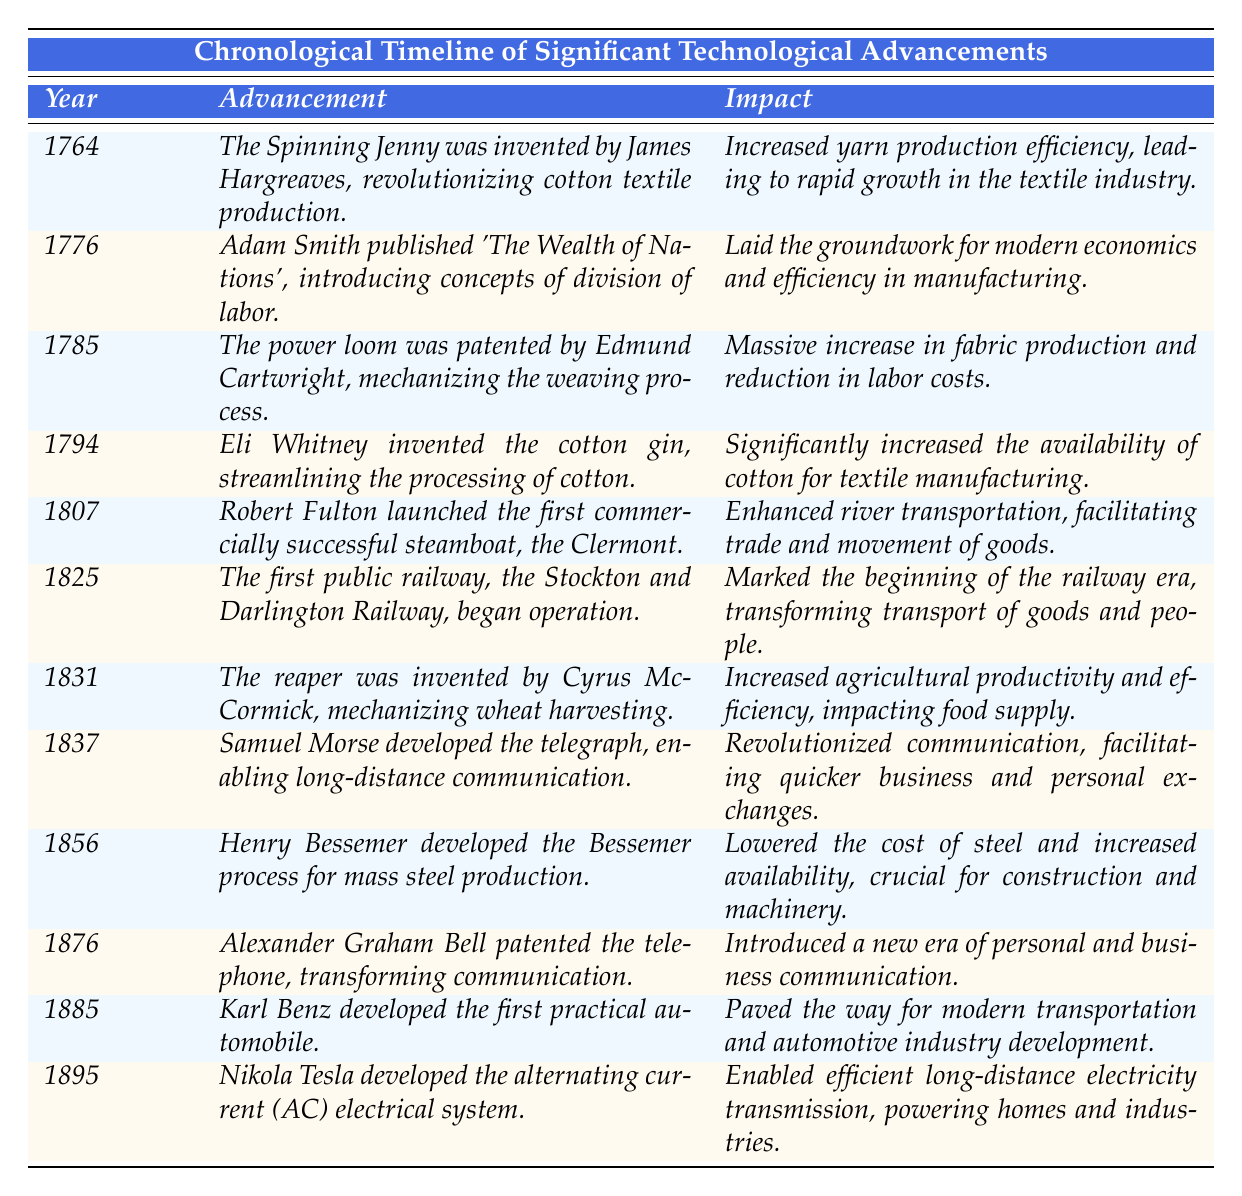What year was the Spinning Jenny invented? According to the table, the Spinning Jenny was invented in the year 1764.
Answer: 1764 What is the advancement that occurred in 1776? The table shows that in 1776, Adam Smith published 'The Wealth of Nations', which introduced concepts of division of labor.
Answer: Adam Smith published 'The Wealth of Nations' Which invention created by Eli Whitney in 1794 significantly increased the availability of cotton? The table specifies that Eli Whitney invented the cotton gin in 1794, which streamlined the processing of cotton and increased its availability.
Answer: Cotton gin In what year did the first public railway begin operation? The table indicates that the first public railway, the Stockton and Darlington Railway, began operation in 1825.
Answer: 1825 What impact did the power loom have on fabric production? The power loom, patented by Edmund Cartwright in 1785, resulted in a massive increase in fabric production and a reduction in labor costs according to the information in the table.
Answer: Massive increase in fabric production and reduced labor costs How many years passed between the invention of the Spinning Jenny and the launching of the first steamboat? The Spinning Jenny was invented in 1764 and the first steamboat was launched in 1807. The difference is 1807 - 1764 = 43 years.
Answer: 43 years Was the telephone patented before or after the alternating current electrical system was developed? The table indicates that the telephone was patented in 1876 and the alternating current electrical system was developed in 1895. Thus, the telephone was patented before the alternating current system.
Answer: Before Calculate the average year of all the advancements listed. Adding all the years together gives: 1764 + 1776 + 1785 + 1794 + 1807 + 1825 + 1831 + 1837 + 1856 + 1876 + 1885 + 1895 = 22,050. There are 12 advancements, so the average year is 22,050 / 12 = 1,837.5, which can be approximated to 1838.
Answer: 1838 Which advancement has the most significant impact on communication, according to the table? The table attributes revolutionary changes in communication to the telegraph, developed by Samuel Morse in 1837, which enabled long-distance communication and facilitated quicker exchanges.
Answer: The telegraph Did any advancements occur in the 1800s? Yes, the table lists several advancements in the 1800s: the steamboat in 1807, the railway in 1825, the reaper in 1831, the telegraph in 1837, the Bessemer process in 1856, the telephone in 1876, the automobile in 1885, and the AC electrical system in 1895.
Answer: Yes 